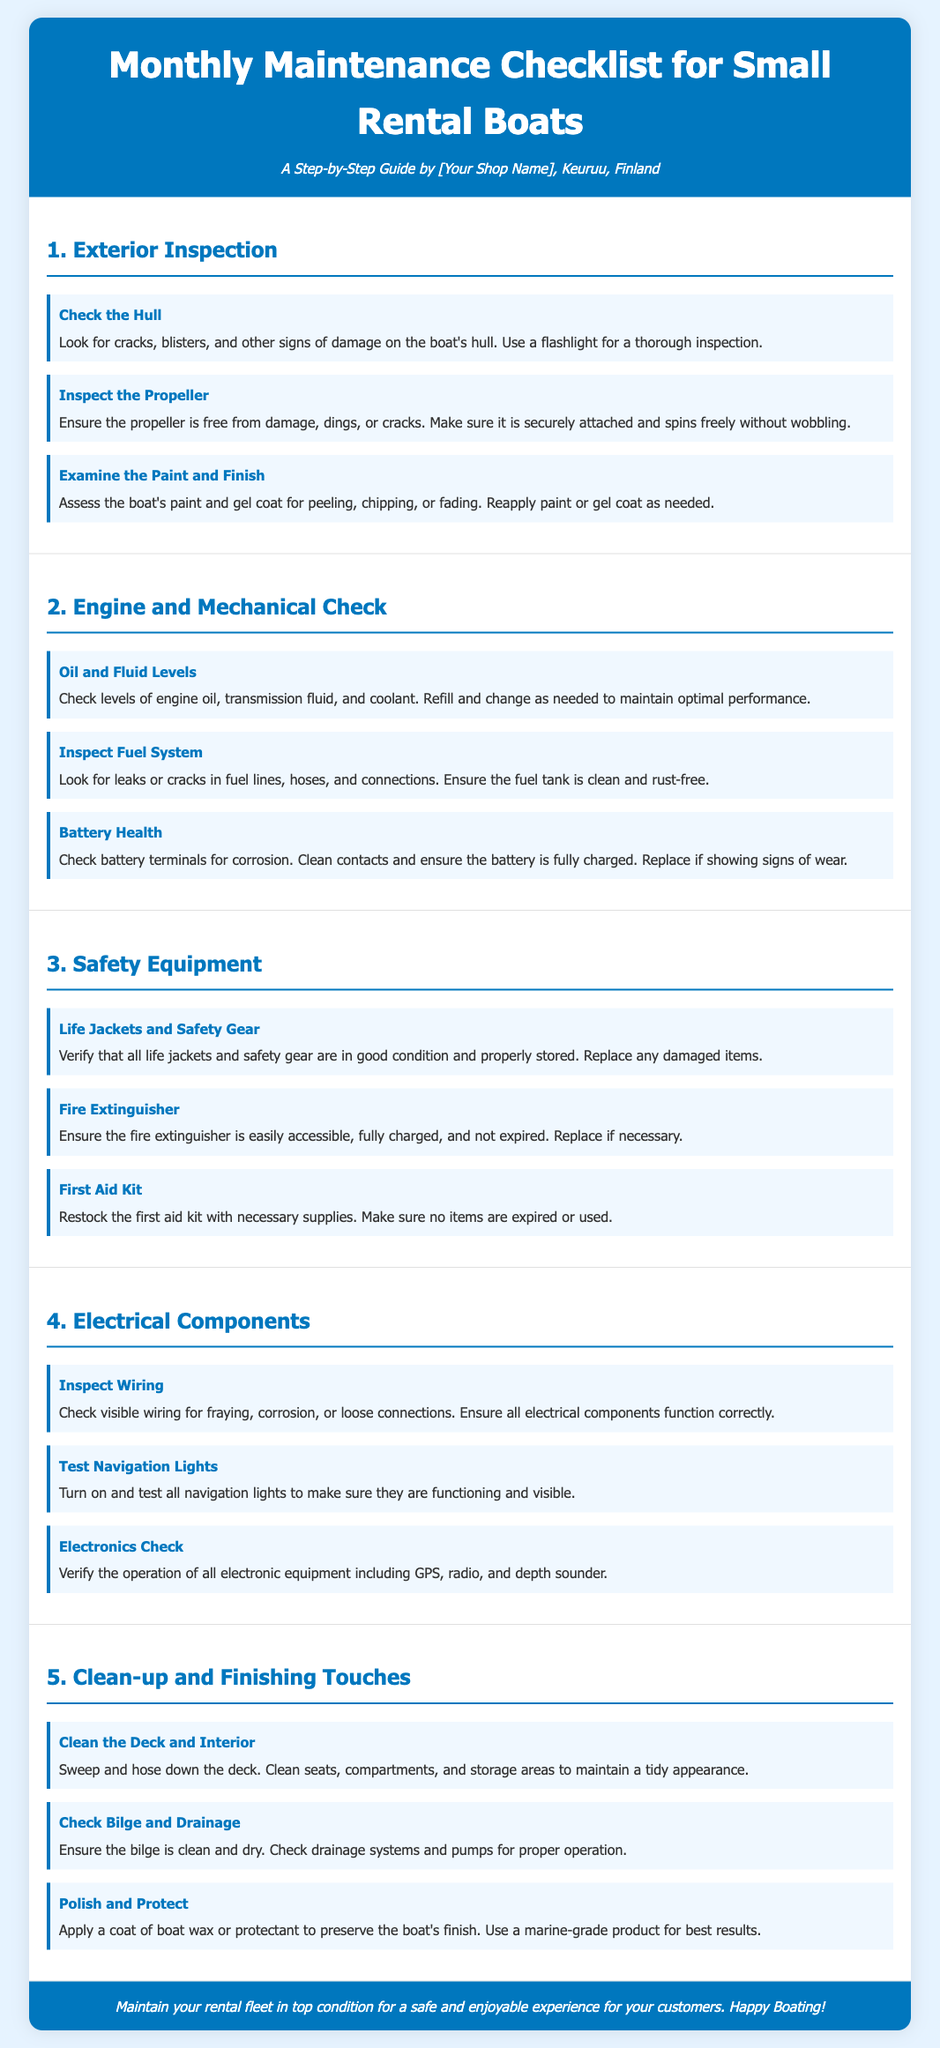What is the title of the document? The title is prominently displayed at the top of the document, providing an overview of its content.
Answer: Monthly Maintenance Checklist for Small Rental Boats How many steps are there in the "Safety Equipment" section? The "Safety Equipment" section contains three steps listed to ensure safety gear is inspected.
Answer: 3 What should be checked in the "Engine and Mechanical Check"? This section includes steps related to the maintenance of the boat's engine and mechanical components for optimal performance.
Answer: Oil and Fluid Levels, Inspect Fuel System, Battery Health What color is the background of the document? The style specifies a particular color for the background which enhances readability and presentation.
Answer: Light blue Which step involves ensuring that life jackets are in good condition? This step is specifically focused on the verification and management of safety equipment for customers' safety.
Answer: Life Jackets and Safety Gear How should the hull of the boat be inspected? The document advises on the method used to check for damage on the hull to maintain boat safety.
Answer: Use a flashlight What is the purpose of applying wax in the maintenance checklist? This step aims to protect the boat's surface and maintain its appearance after performing other maintenance tasks.
Answer: Preserve the boat's finish Is there a specific order suggested for the steps? The steps are structured in a sequential manner to ensure comprehensive maintenance is performed monthly.
Answer: Yes What color should the navigation lights be tested? Testing the navigation lights is an important aspect of electrical safety on the boat that needs attention.
Answer: All colors 